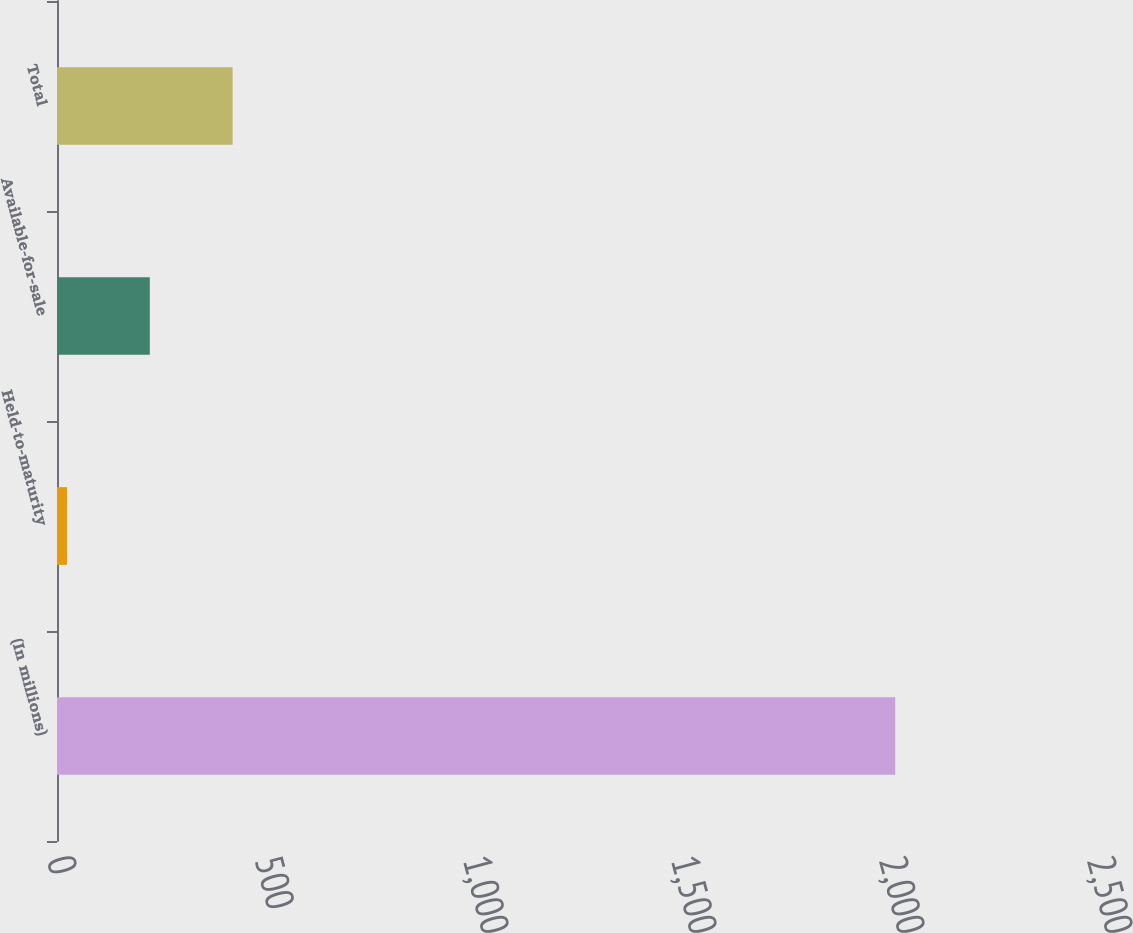Convert chart. <chart><loc_0><loc_0><loc_500><loc_500><bar_chart><fcel>(In millions)<fcel>Held-to-maturity<fcel>Available-for-sale<fcel>Total<nl><fcel>2015<fcel>24<fcel>223.1<fcel>422.2<nl></chart> 